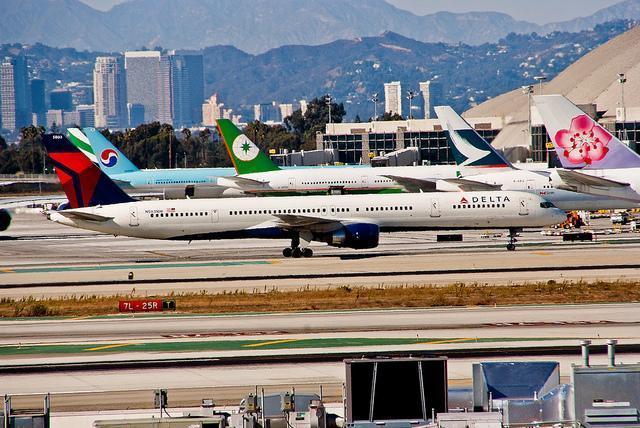How many airplanes are visible?
Give a very brief answer. 5. 